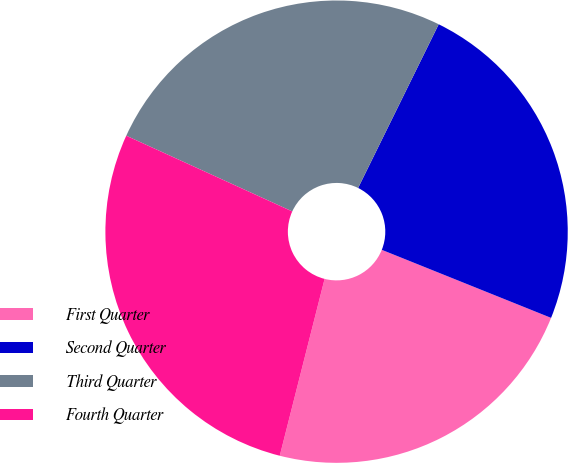<chart> <loc_0><loc_0><loc_500><loc_500><pie_chart><fcel>First Quarter<fcel>Second Quarter<fcel>Third Quarter<fcel>Fourth Quarter<nl><fcel>22.87%<fcel>23.8%<fcel>25.47%<fcel>27.86%<nl></chart> 